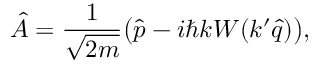<formula> <loc_0><loc_0><loc_500><loc_500>\hat { A } = \frac { 1 } { \sqrt { 2 m } } \left ( \hat { p } - i \hbar { k } W ( k ^ { \prime } \hat { q } ) \right ) ,</formula> 